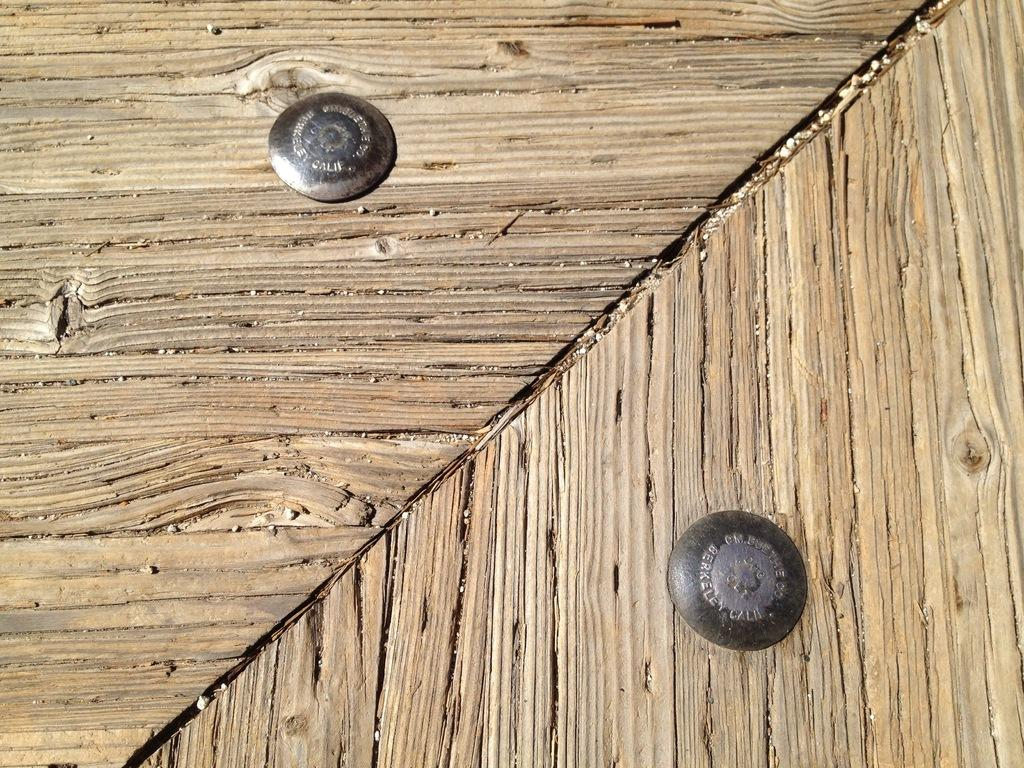What type of surface is visible in the image? There is a wooden surface in the image. Can you describe the color of the wooden surface? The wooden surface is brown in color. Are there any objects attached to the wooden surface? Yes, there are two nails on the wooden surface. What type of club is being used to hit the square in the image? There is no club or square present in the image; it only features a wooden surface with two nails. 